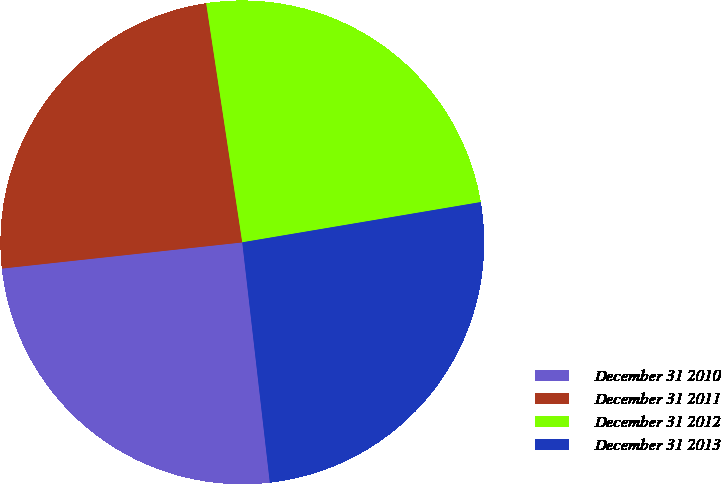<chart> <loc_0><loc_0><loc_500><loc_500><pie_chart><fcel>December 31 2010<fcel>December 31 2011<fcel>December 31 2012<fcel>December 31 2013<nl><fcel>25.09%<fcel>24.34%<fcel>24.72%<fcel>25.84%<nl></chart> 